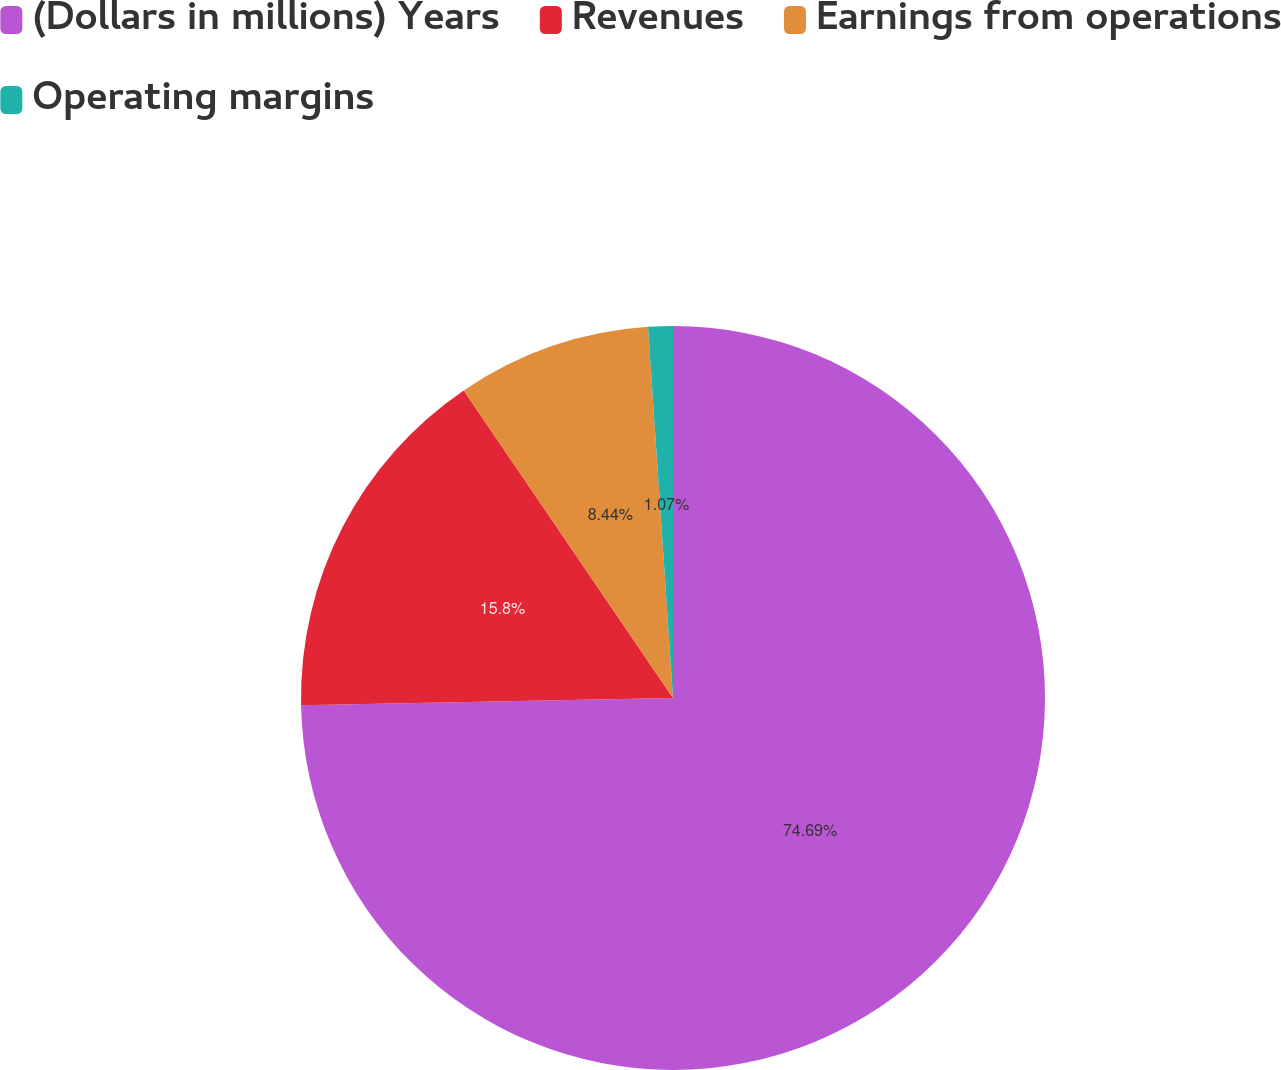Convert chart. <chart><loc_0><loc_0><loc_500><loc_500><pie_chart><fcel>(Dollars in millions) Years<fcel>Revenues<fcel>Earnings from operations<fcel>Operating margins<nl><fcel>74.69%<fcel>15.8%<fcel>8.44%<fcel>1.07%<nl></chart> 